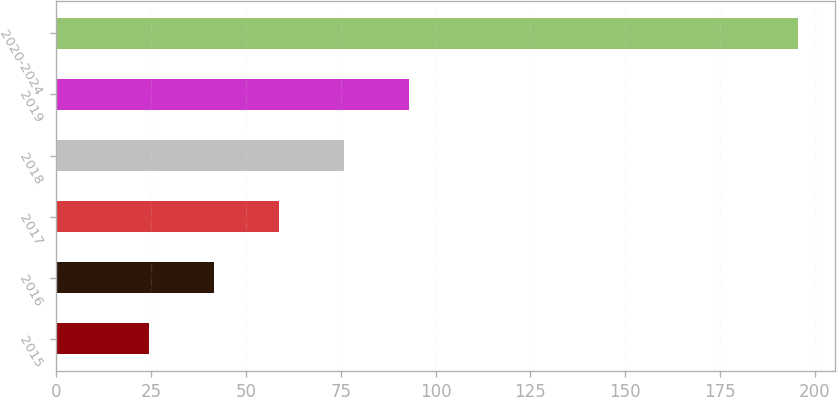Convert chart to OTSL. <chart><loc_0><loc_0><loc_500><loc_500><bar_chart><fcel>2015<fcel>2016<fcel>2017<fcel>2018<fcel>2019<fcel>2020-2024<nl><fcel>24.5<fcel>41.59<fcel>58.68<fcel>75.77<fcel>92.86<fcel>195.4<nl></chart> 